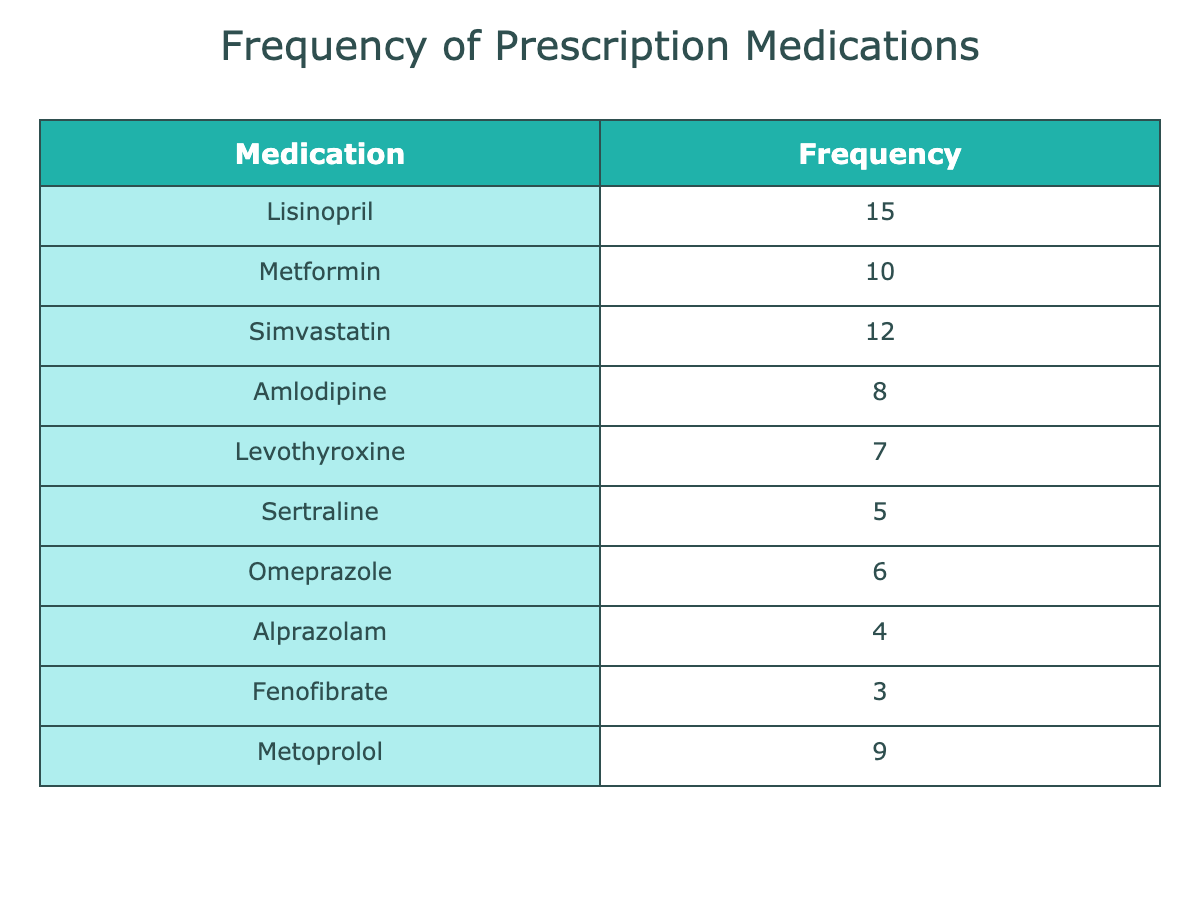What is the most frequently prescribed medication? The table lists the medications along with their frequencies. Looking through the 'Frequency' column, Lisinopril has the highest count of 15.
Answer: Lisinopril How many different medications are listed in the table? The table displays each medication in the 'Medication' column. Counting the unique medications, we find there are 10 different medications listed.
Answer: 10 Is there a medication in the table with a frequency of 6 or higher? By examining the 'Frequency' column, I can confirm that several medications, specifically Lisinopril, Metformin, Simvastatin, Amlodipine, Omeprazole, and Metoprolol, have frequencies of 6 or greater.
Answer: Yes What is the total frequency of all medications combined? To find the total frequency, I will sum all the values in the 'Frequency' column: (15 + 10 + 12 + 8 + 7 + 5 + 6 + 4 + 3 + 9) = 69. Therefore, the total frequency is 69.
Answer: 69 Which medication is the least frequently prescribed? Looking at the 'Frequency' column, Fenofibrate has the lowest frequency with the count of 3. Therefore, it is the least frequently prescribed medication.
Answer: Fenofibrate What is the average frequency of the medications listed in the table? The average frequency is calculated by dividing the total frequency (69) by the number of medications (10). So, 69 divided by 10 equals 6.9.
Answer: 6.9 Are there any medications that are prescribed more than 10 times? By reviewing the 'Frequency' column, I can see that only Lisinopril (15), Metformin (10), and Simvastatin (12) exceed the count of 10.
Answer: Yes What is the difference in frequency between the most and least prescribed medications? The most prescribed medication, Lisinopril, has a frequency of 15, while the least prescribed medication, Fenofibrate, has a frequency of 3. The difference is calculated as 15 - 3 = 12.
Answer: 12 How many medications are prescribed fewer than 5 times? Checking the 'Frequency' column, the medications Alprazolam (4) and Fenofibrate (3) are the only ones prescribed fewer than 5 times, totaling two medications.
Answer: 2 